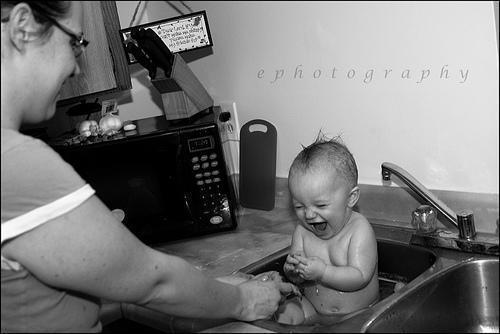Who is most likely bathing the baby?
Answer the question by selecting the correct answer among the 4 following choices.
Options: Sister, nanny, grandmother, mom. Mom. 